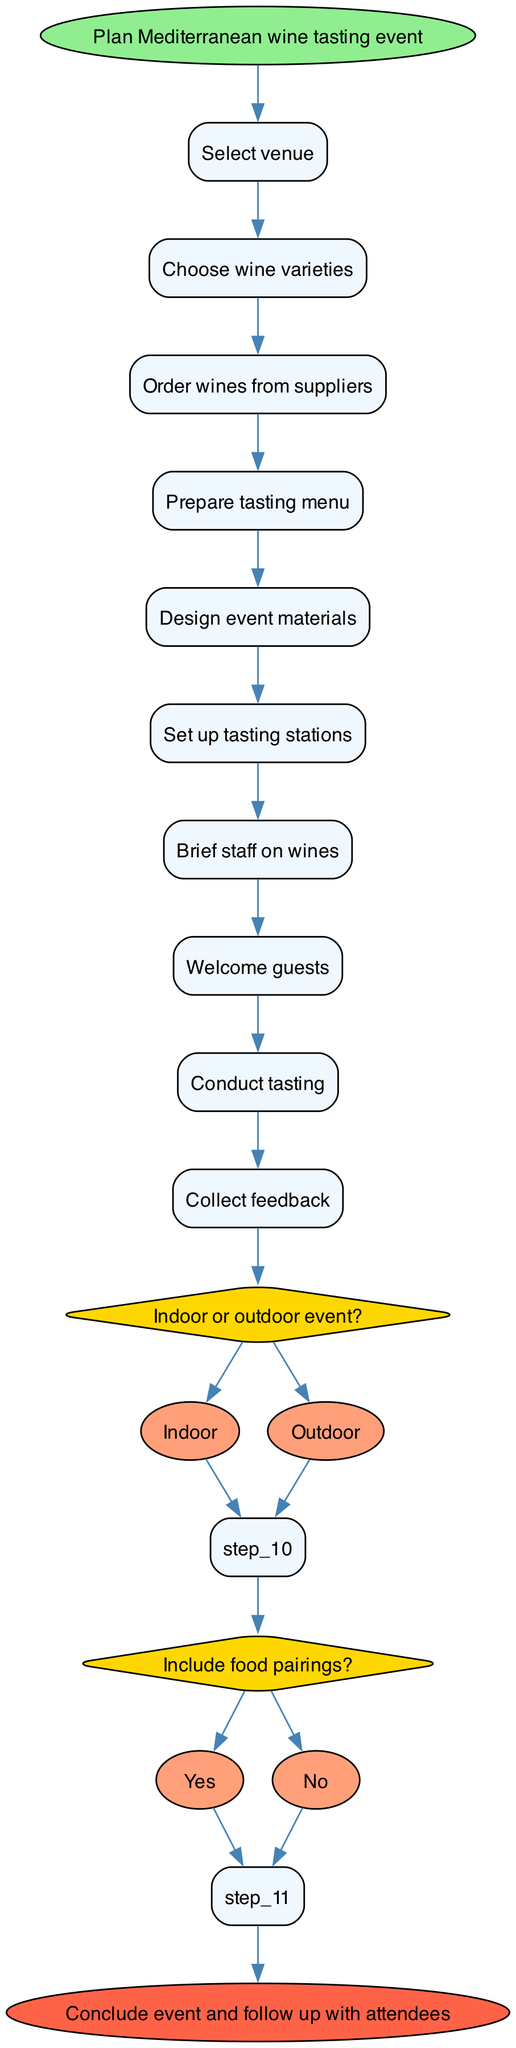What is the starting point of the flowchart? The starting point of the flowchart is the "Plan Mediterranean wine tasting event" node, which is the initiation of the process depicted in the diagram.
Answer: Plan Mediterranean wine tasting event How many steps are there in total? There are 10 steps in total as listed in the diagram, counting both the actions and decisions.
Answer: 10 What is the last step before concluding the event? The last step before concluding the event is "Collect feedback," which is the final action taken before ending the process.
Answer: Collect feedback What question is asked regarding the event's setup? The diagram asks the question "Indoor or outdoor event?", which is a key decision point affecting how the event will be organized.
Answer: Indoor or outdoor event? How many options are provided for the decision about food pairings? There are 2 options provided for the decision regarding food pairings: "Yes" and "No." This shows that the event can include food or not.
Answer: 2 Which step follows after "Order wines from suppliers"? After "Order wines from suppliers," the next step is "Prepare tasting menu," indicating that menu preparation occurs after wine ordering.
Answer: Prepare tasting menu What is the first decision point in the flowchart? The first decision point in the flowchart is "Indoor or outdoor event?", which determines how the event will be set up at the beginning of the process.
Answer: Indoor or outdoor event? What are the two options available for the first decision? The two options available for the first decision "Indoor or outdoor event?" are "Indoor" and "Outdoor," indicating the venue choice for the event.
Answer: Indoor, Outdoor Which step is linked directly from the option "Yes" in food pairings? The step linked directly from the "Yes" option in food pairings is "Design event materials," indicating that if food is included, the design materials will follow.
Answer: Design event materials 